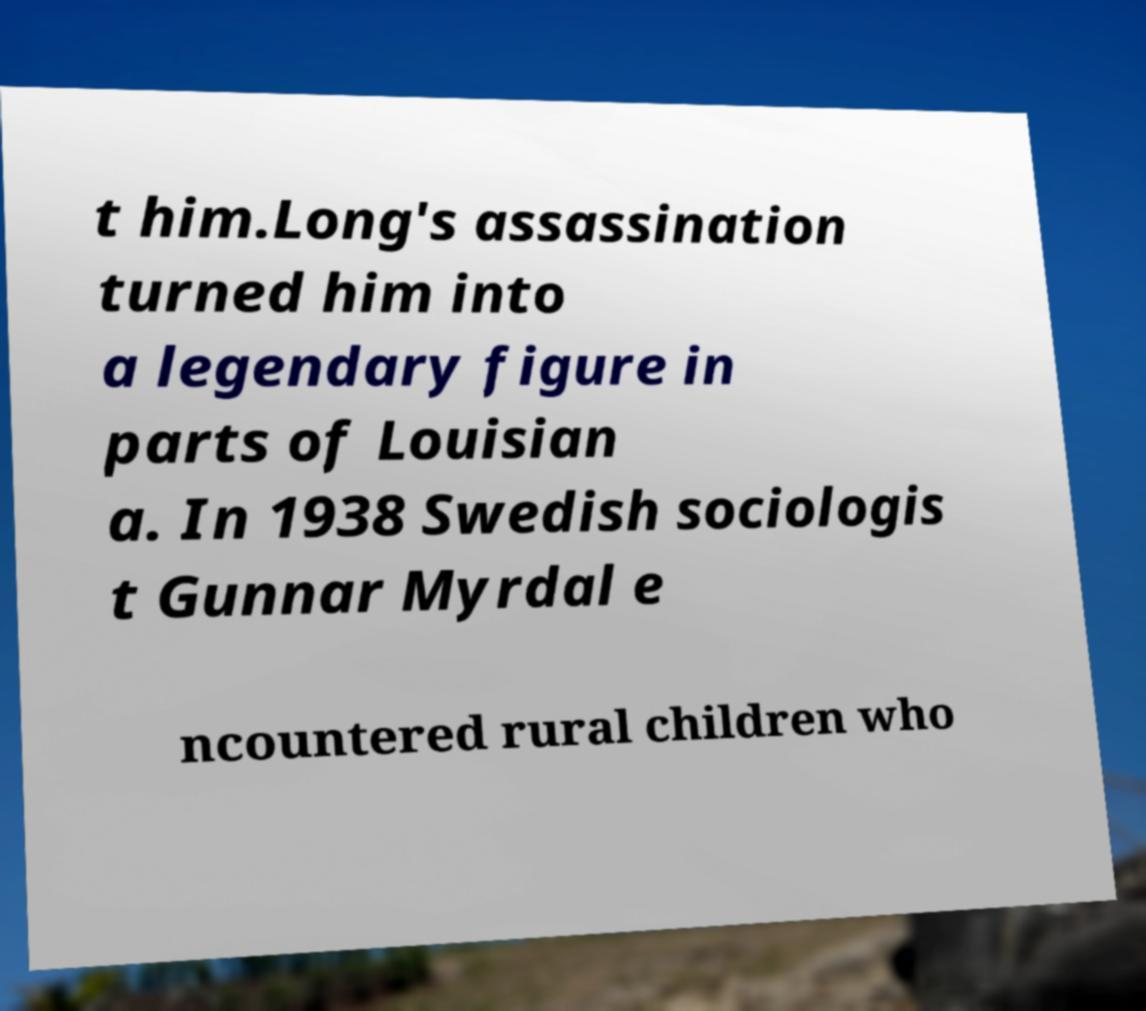Could you extract and type out the text from this image? t him.Long's assassination turned him into a legendary figure in parts of Louisian a. In 1938 Swedish sociologis t Gunnar Myrdal e ncountered rural children who 